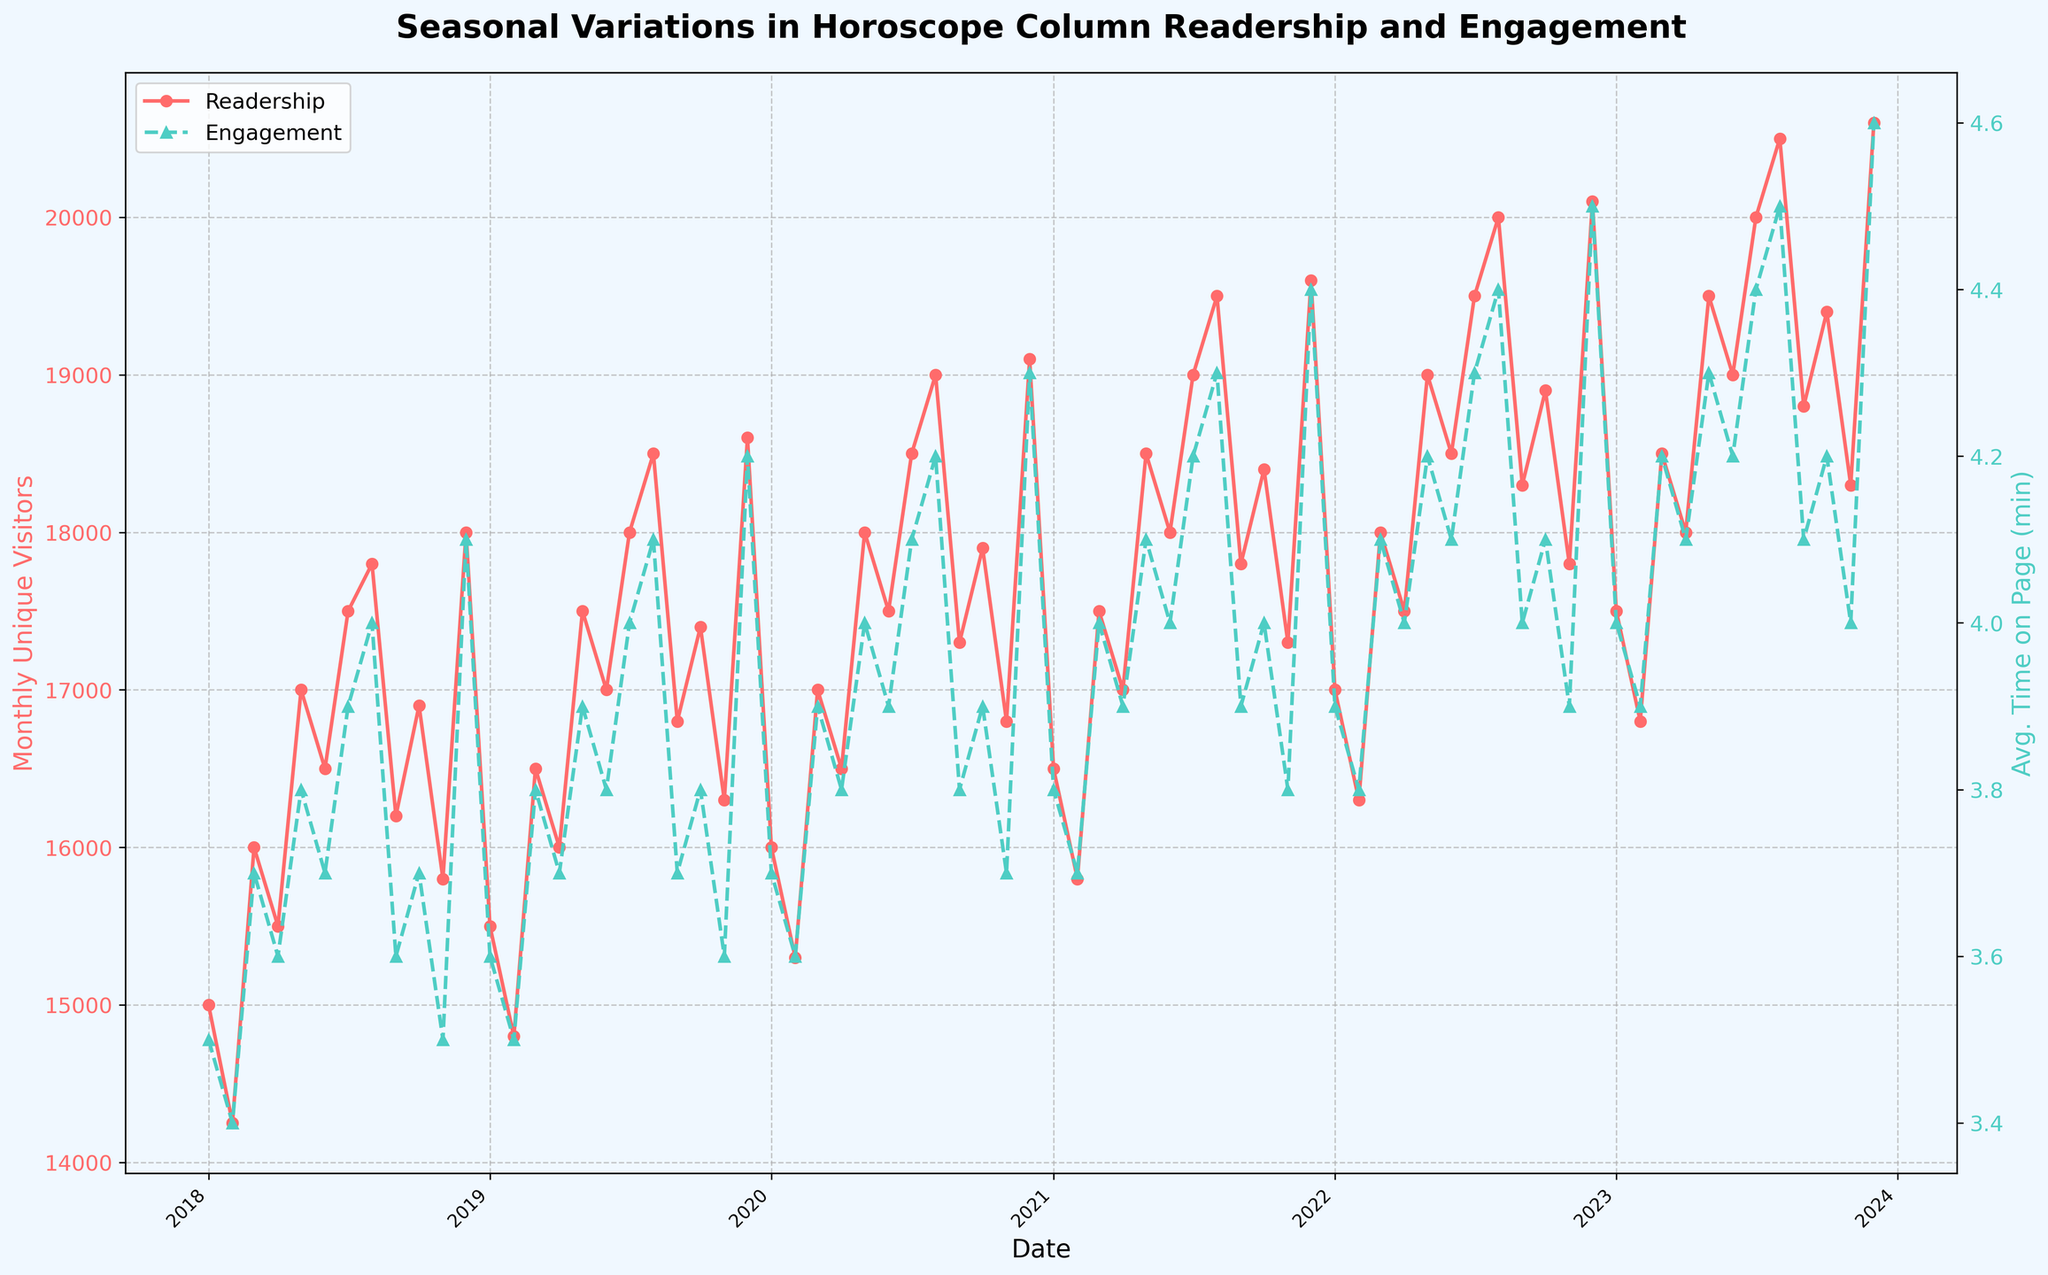What is the title of the plot? The title is typically located at the top of the plot and clearly indicates the focus of the visualization.
Answer: Seasonal Variations in Horoscope Column Readership and Engagement What is the color of the line representing the Readership data? The color of the line can be identified by looking at the line that corresponds to Monthly Unique Visitors in the legend.
Answer: Red What trend do you observe for the Engagement data over the five years? To identify the trend, observe the line representing the Engagement data. Note any patterns, such as increases, decreases, or seasonal fluctuations over time.
Answer: Increasing Which year had the peak readership in December? To find this, look at the data points for December of each year and identify which one has the highest value on the Readership line.
Answer: 2023 How does the average time on page in December 2021 compare to December 2018? Check the Engagement data points for both Decembers and compare their values to determine if it has increased, decreased, or remained the same.
Answer: Higher Which month generally shows higher readership: July or February? Compare the data points for July and February across multiple years to determine which month tends to have higher values on the Readership line.
Answer: July During which year did both readership and engagement achieve consistently high values? Look for a year where both the Readership and Engagement lines show higher values throughout most months. Identify the year with the most consistent peak performance in both metrics.
Answer: 2023 How many major ticks are on the x-axis, and what do they represent? Count the number of major ticks on the x-axis and note the years indicated by these ticks.
Answer: 6, representing years from 2018 to 2023 Which month in 2023 had the highest engagement? Find the month with the highest value on the Engagement line within the year 2023.
Answer: December What is the range of Readership data in 2019? Identify the highest and lowest values of the Readership data within the year 2019 and calculate the difference between them.
Answer: 18600 - 14800 = 3800 